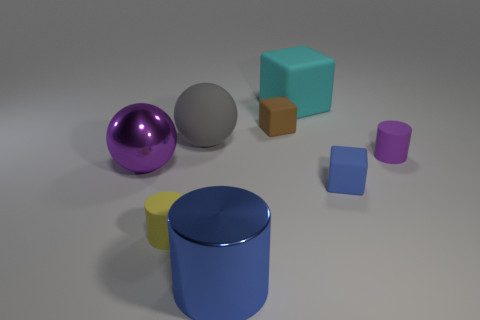What is the color of the cylinder that is the same material as the big purple sphere?
Give a very brief answer. Blue. How many other cylinders have the same size as the blue metallic cylinder?
Offer a very short reply. 0. Is the material of the cylinder that is right of the brown thing the same as the large purple sphere?
Provide a succinct answer. No. Are there fewer yellow rubber things that are right of the purple cylinder than tiny purple rubber objects?
Ensure brevity in your answer.  Yes. There is a big matte object on the left side of the metal cylinder; what shape is it?
Your response must be concise. Sphere. There is a brown thing that is the same size as the purple cylinder; what is its shape?
Offer a very short reply. Cube. Is there another small purple metal thing of the same shape as the purple shiny object?
Offer a very short reply. No. There is a shiny object that is right of the purple sphere; does it have the same shape as the tiny thing that is in front of the blue matte block?
Ensure brevity in your answer.  Yes. What is the material of the gray ball that is the same size as the cyan rubber thing?
Your response must be concise. Rubber. What number of other things are made of the same material as the purple cylinder?
Offer a very short reply. 5. 